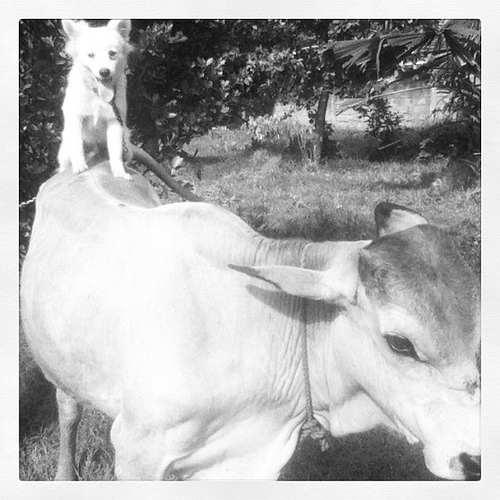How many dogs are in the picture? There is one dog in the picture, comfortably perched atop the back of a gentle cow, which is a rather unusual and charming sight. 